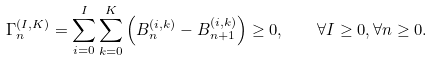<formula> <loc_0><loc_0><loc_500><loc_500>\Gamma _ { n } ^ { ( I , K ) } = \sum _ { i = 0 } ^ { I } \sum _ { k = 0 } ^ { K } \left ( B ^ { ( i , k ) } _ { n } - B ^ { ( i , k ) } _ { n + 1 } \right ) \geq 0 , \quad \forall I \geq 0 , \forall n \geq 0 .</formula> 